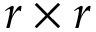Convert formula to latex. <formula><loc_0><loc_0><loc_500><loc_500>r \times r</formula> 